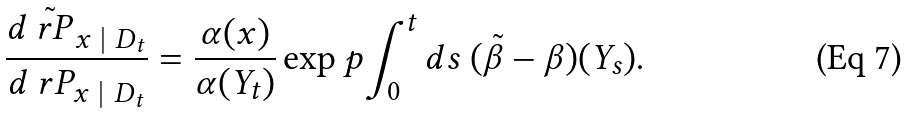Convert formula to latex. <formula><loc_0><loc_0><loc_500><loc_500>\frac { d \tilde { \ r P } _ { x \ | \ D _ { t } } } { d \ r P _ { x \ | \ D _ { t } } } = \frac { \alpha ( x ) } { \alpha ( Y _ { t } ) } \exp p { \int _ { 0 } ^ { t } d s \ ( \tilde { \beta } - \beta ) ( Y _ { s } ) } .</formula> 